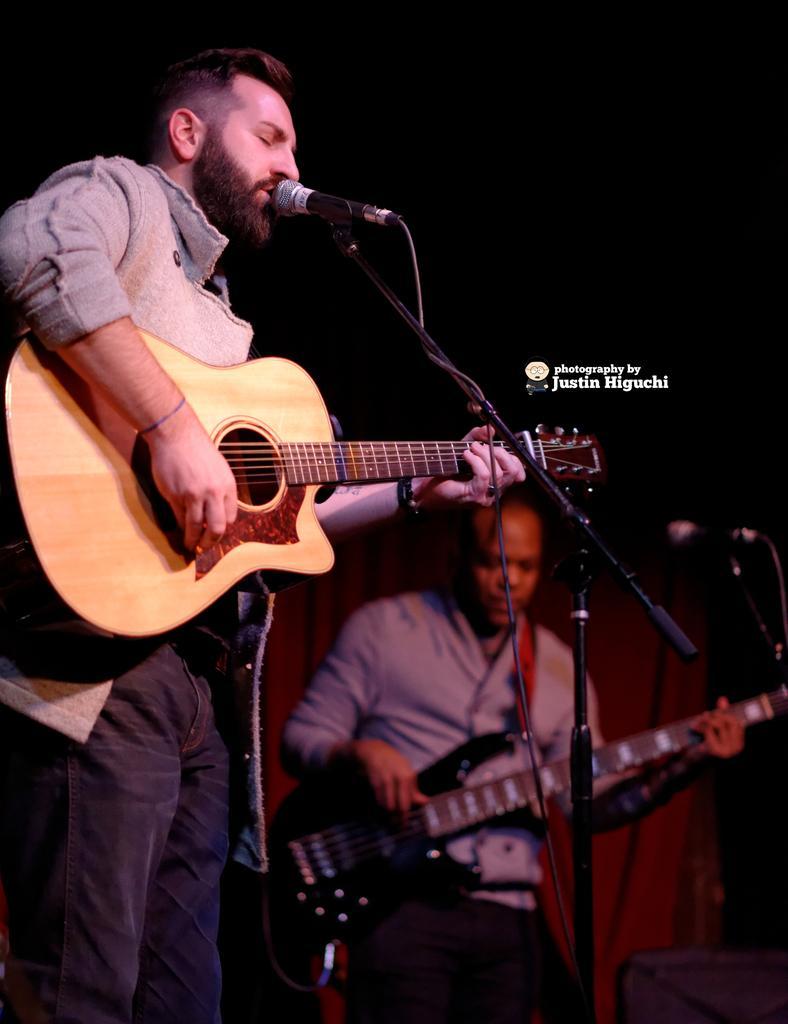How would you summarize this image in a sentence or two? In this picture there is two persons one person is playing a guitar and singing on a microphone and other person is playing a guitar. 